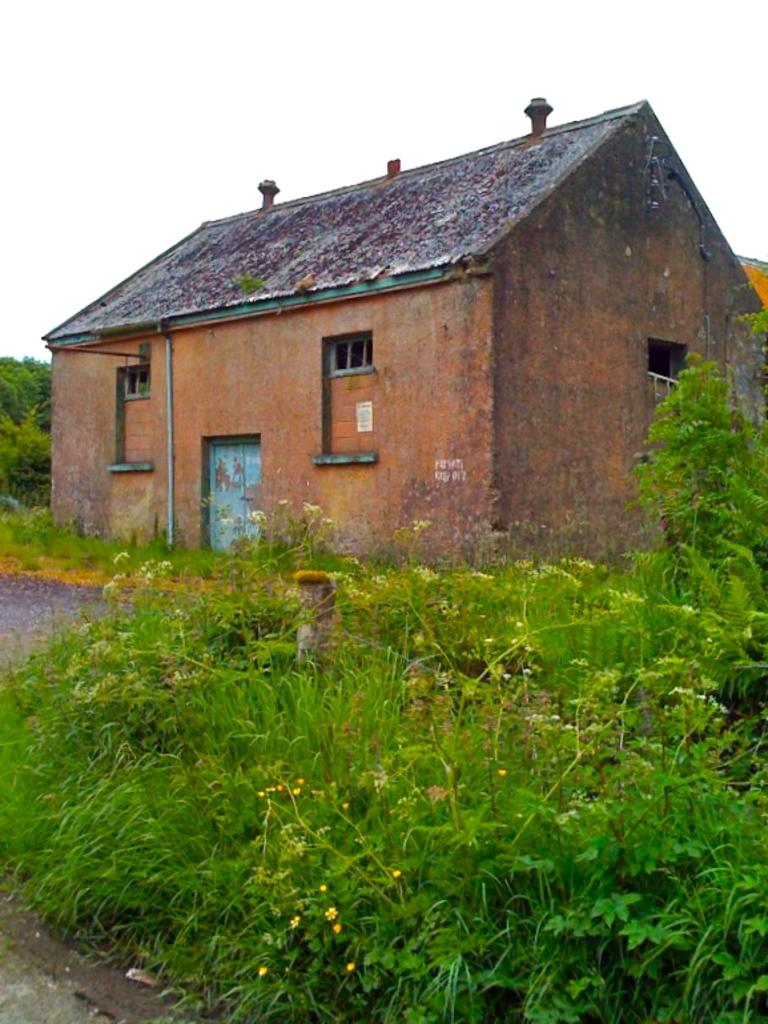What is the main structure in the center of the image? There is a house in the center of the image. Where is the door located on the house? The door is on the left side of the house. What type of vegetation can be seen on the right side of the image? There are plants on the right side of the image. Are there any plants visible on the left side of the image? Yes, there are plants on the left side of the image. Can you see any animals from the zoo in the image? There is no zoo or animals visible in the image; it features a house with plants on both sides. 